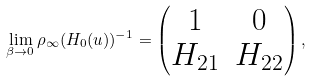Convert formula to latex. <formula><loc_0><loc_0><loc_500><loc_500>\lim _ { \beta \to 0 } \rho _ { \infty } ( H _ { 0 } ( u ) ) ^ { - 1 } = \begin{pmatrix} 1 & 0 \\ H _ { 2 1 } & H _ { 2 2 } \end{pmatrix} ,</formula> 